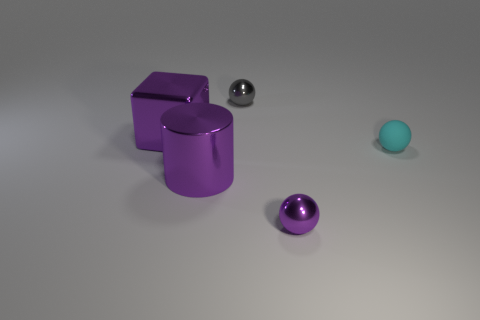Add 4 large things. How many objects exist? 9 Subtract all gray metallic balls. How many balls are left? 2 Subtract all purple balls. How many balls are left? 2 Subtract 2 spheres. How many spheres are left? 1 Subtract all blue balls. Subtract all gray cylinders. How many balls are left? 3 Subtract all purple cylinders. How many cyan balls are left? 1 Subtract all purple shiny cubes. Subtract all purple balls. How many objects are left? 3 Add 2 small metallic spheres. How many small metallic spheres are left? 4 Add 1 balls. How many balls exist? 4 Subtract 0 cyan cubes. How many objects are left? 5 